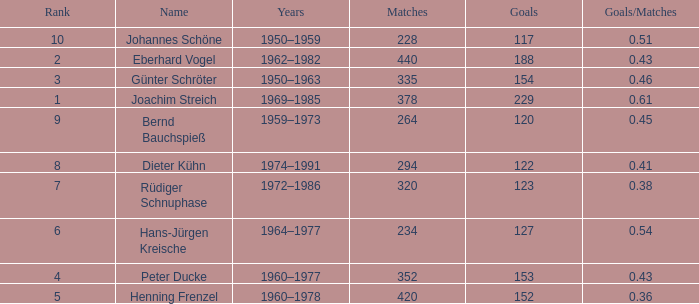How many goals/matches have 153 as the goals with matches greater than 352? None. 